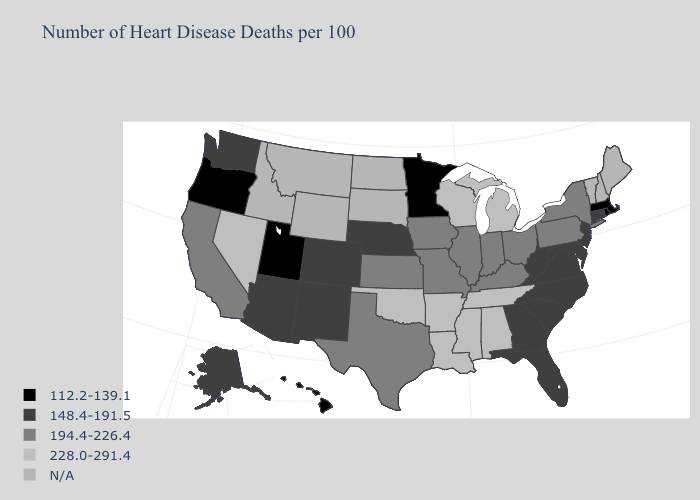What is the value of Washington?
Concise answer only. 148.4-191.5. Name the states that have a value in the range 194.4-226.4?
Give a very brief answer. California, Illinois, Indiana, Iowa, Kansas, Kentucky, Missouri, New York, Ohio, Pennsylvania, Texas. Does West Virginia have the highest value in the South?
Concise answer only. No. What is the value of New York?
Be succinct. 194.4-226.4. What is the value of Missouri?
Answer briefly. 194.4-226.4. Which states have the lowest value in the West?
Answer briefly. Hawaii, Oregon, Utah. Which states have the highest value in the USA?
Quick response, please. Alabama, Arkansas, Louisiana, Michigan, Mississippi, Nevada, Oklahoma, Tennessee, Wisconsin. Among the states that border Missouri , which have the highest value?
Write a very short answer. Arkansas, Oklahoma, Tennessee. Which states have the highest value in the USA?
Answer briefly. Alabama, Arkansas, Louisiana, Michigan, Mississippi, Nevada, Oklahoma, Tennessee, Wisconsin. What is the lowest value in the USA?
Write a very short answer. 112.2-139.1. What is the lowest value in the West?
Short answer required. 112.2-139.1. What is the lowest value in the MidWest?
Give a very brief answer. 112.2-139.1. Among the states that border Nebraska , does Iowa have the lowest value?
Give a very brief answer. No. What is the value of Missouri?
Keep it brief. 194.4-226.4. Does Oregon have the lowest value in the West?
Write a very short answer. Yes. 